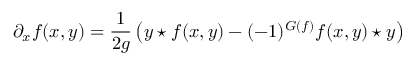<formula> <loc_0><loc_0><loc_500><loc_500>\partial _ { x } f ( x , y ) = \frac { 1 } { 2 g } \left ( y ^ { * } f ( x , y ) - ( - 1 ) ^ { G ( f ) } f ( x , y ) ^ { * } y \right )</formula> 